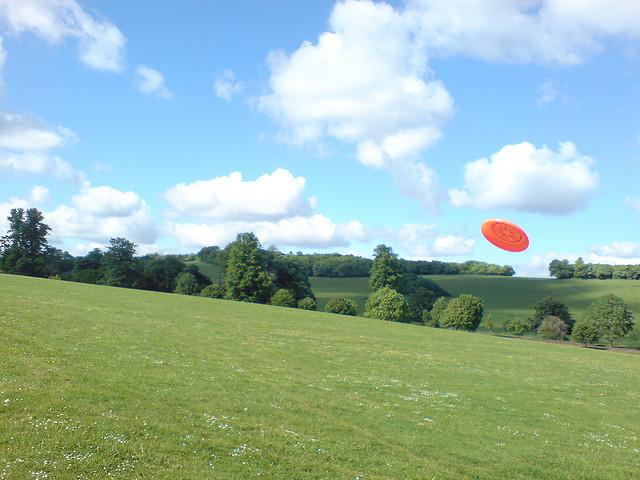What color is the frisbee?
Quick response, please. Orange. Is it a nice day?
Short answer required. Yes. How is the frisbee in the air?
Be succinct. It was thrown. 